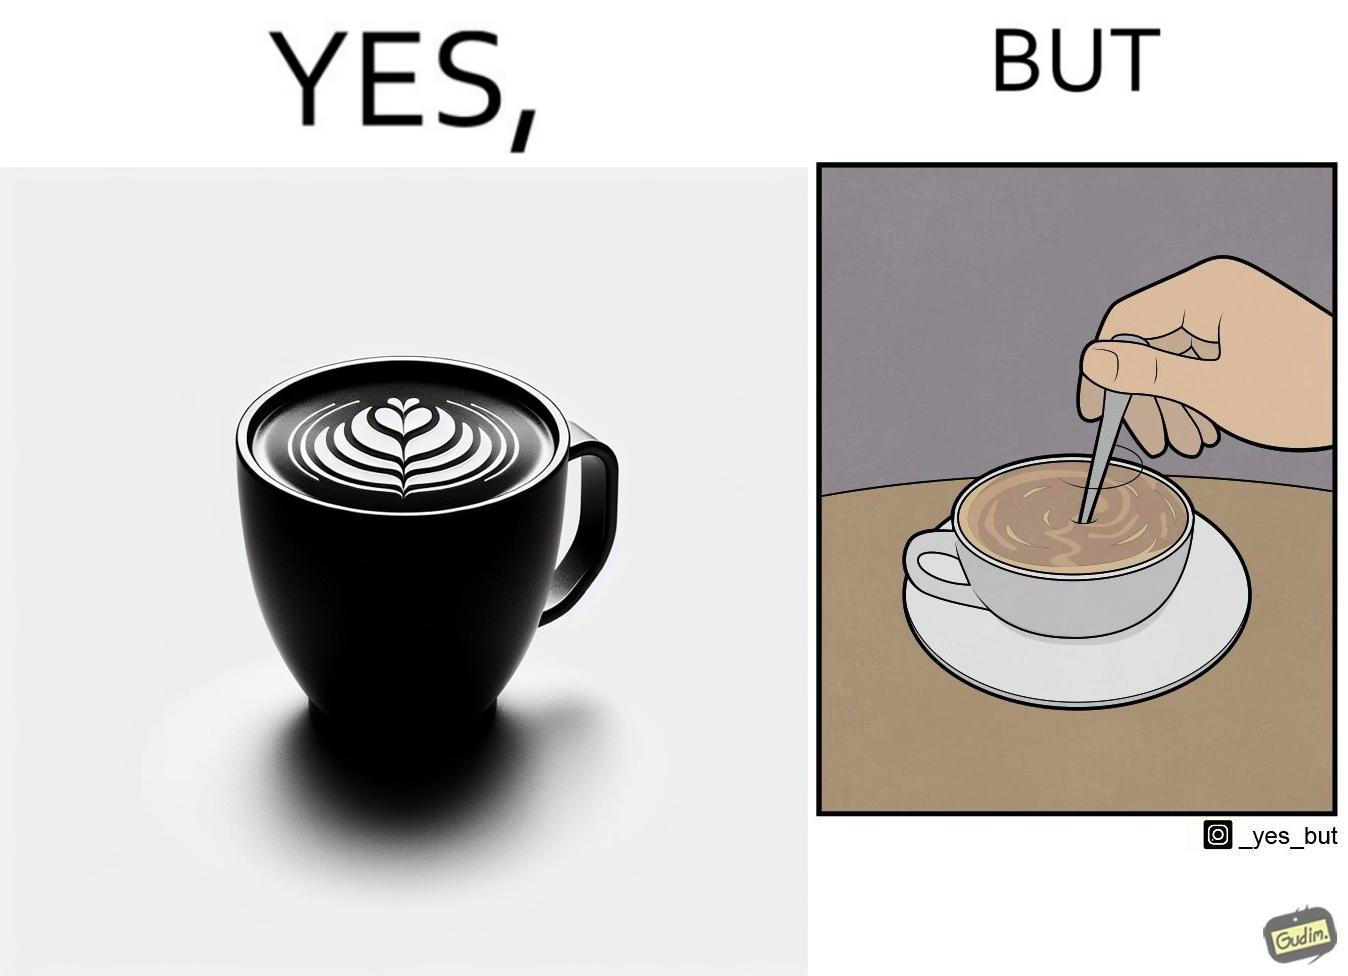Describe the satirical element in this image. The image is ironic, because even when the coffee maker create latte art to make coffee look attractive but it is there just for a short time after that it is vanished 